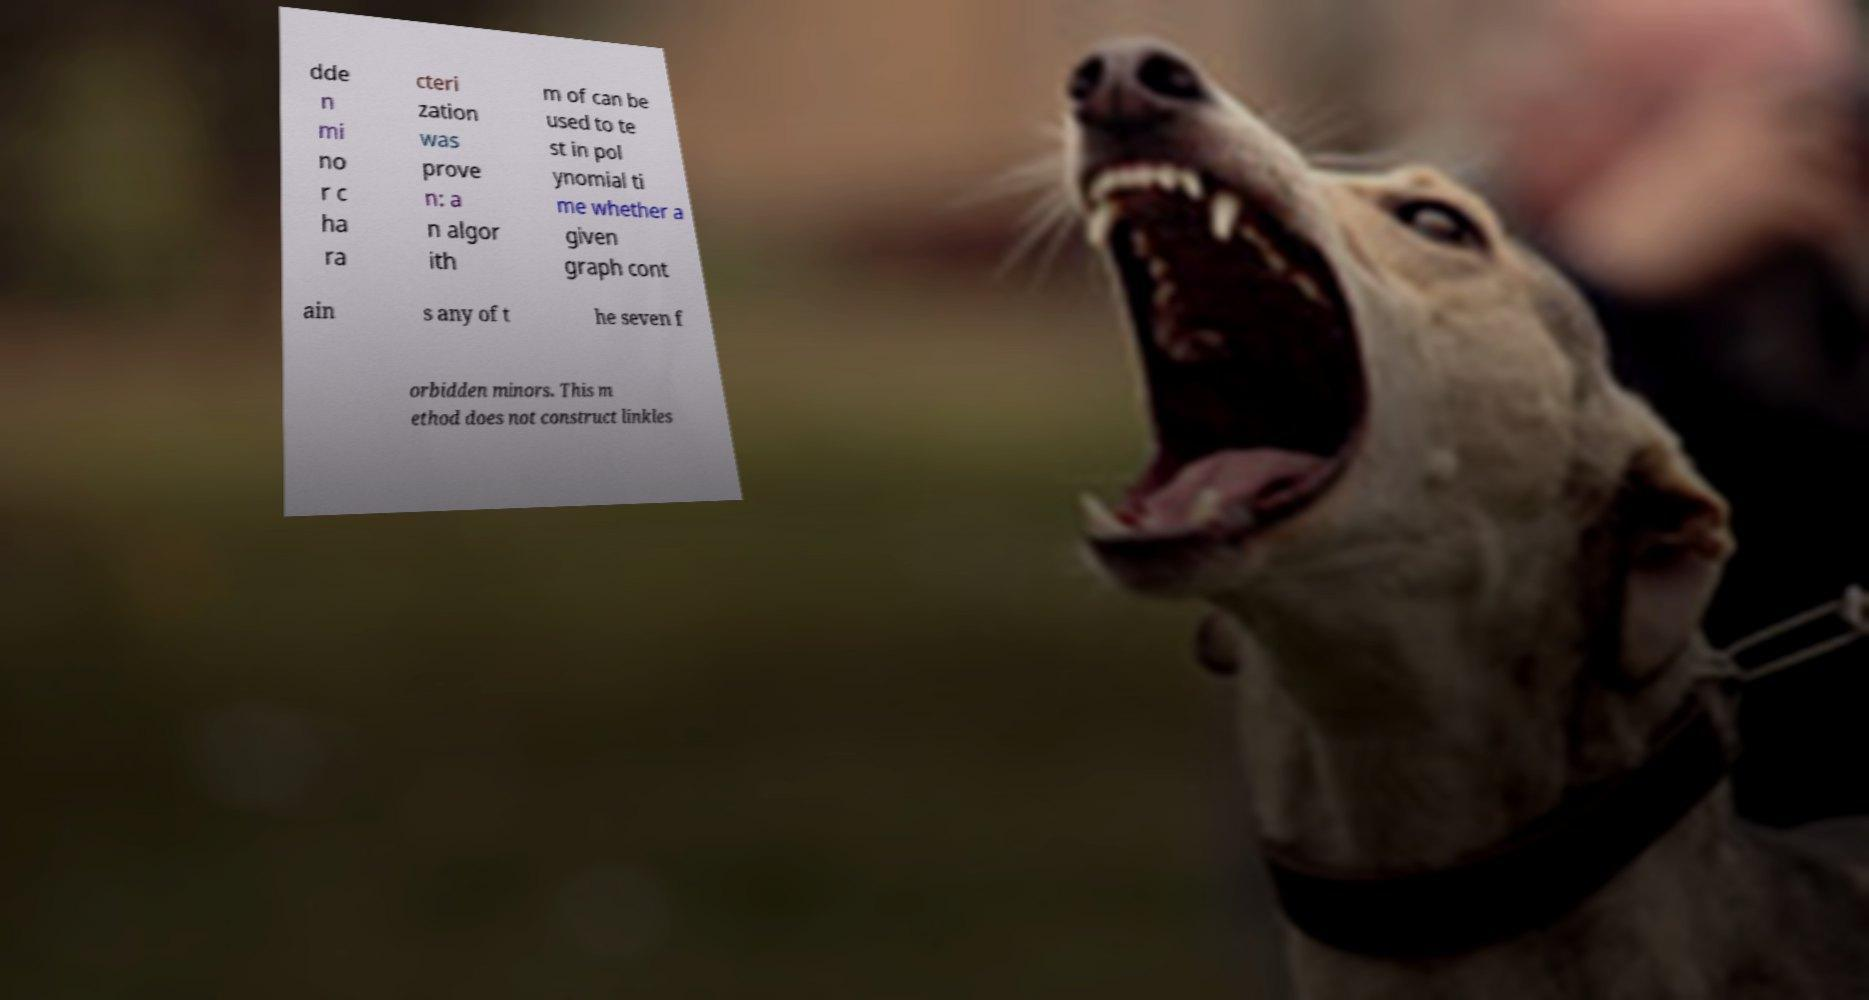For documentation purposes, I need the text within this image transcribed. Could you provide that? dde n mi no r c ha ra cteri zation was prove n: a n algor ith m of can be used to te st in pol ynomial ti me whether a given graph cont ain s any of t he seven f orbidden minors. This m ethod does not construct linkles 